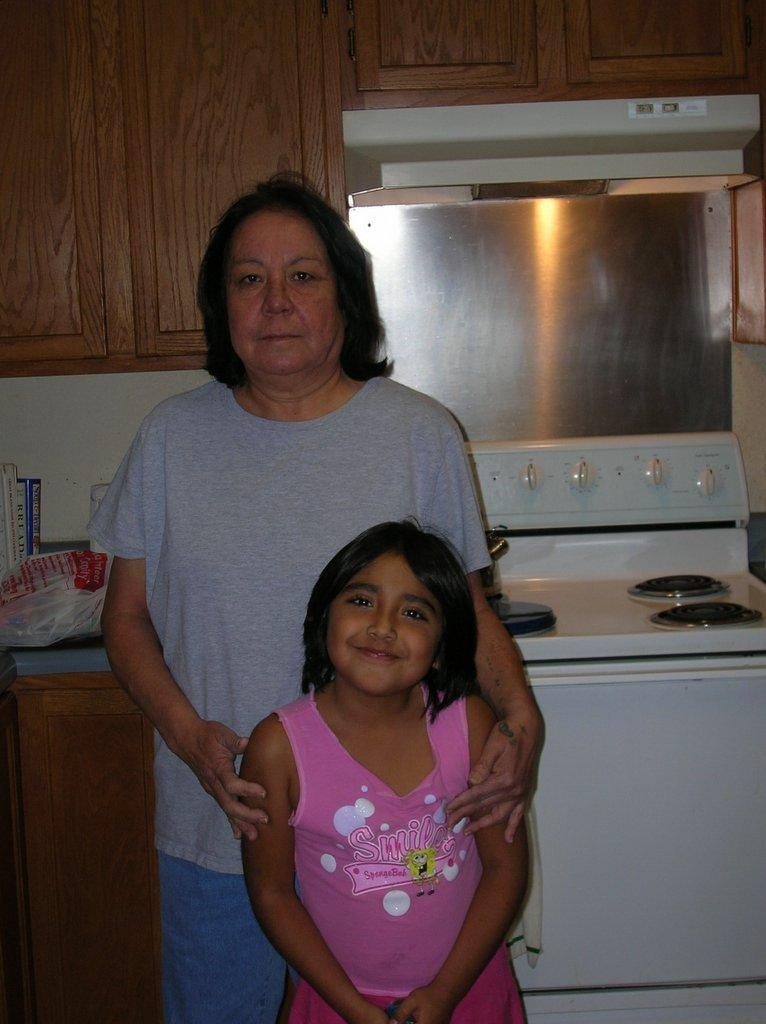<image>
Provide a brief description of the given image. a girl wearing a pink top with the word Smile on it standing with an older lady 